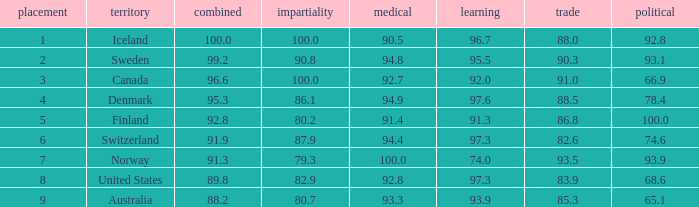What's the country with health being 91.4 Finland. 